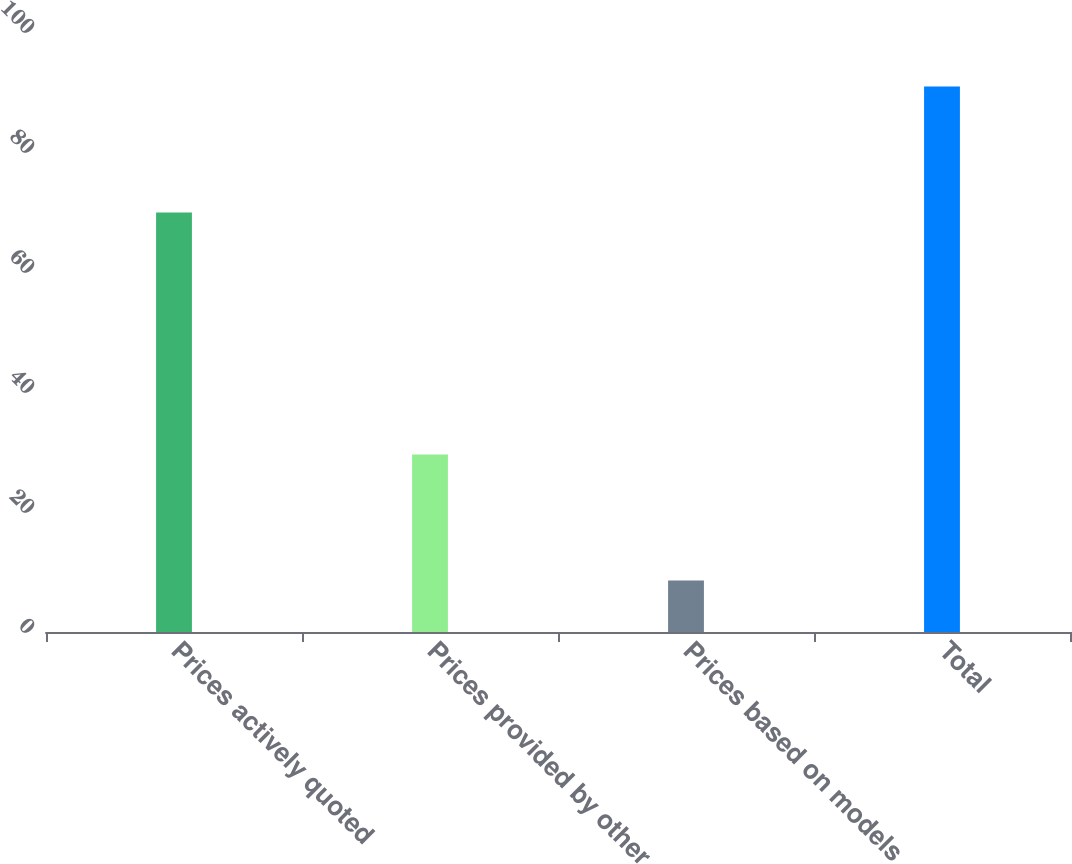Convert chart. <chart><loc_0><loc_0><loc_500><loc_500><bar_chart><fcel>Prices actively quoted<fcel>Prices provided by other<fcel>Prices based on models<fcel>Total<nl><fcel>69.9<fcel>29.6<fcel>8.6<fcel>90.9<nl></chart> 